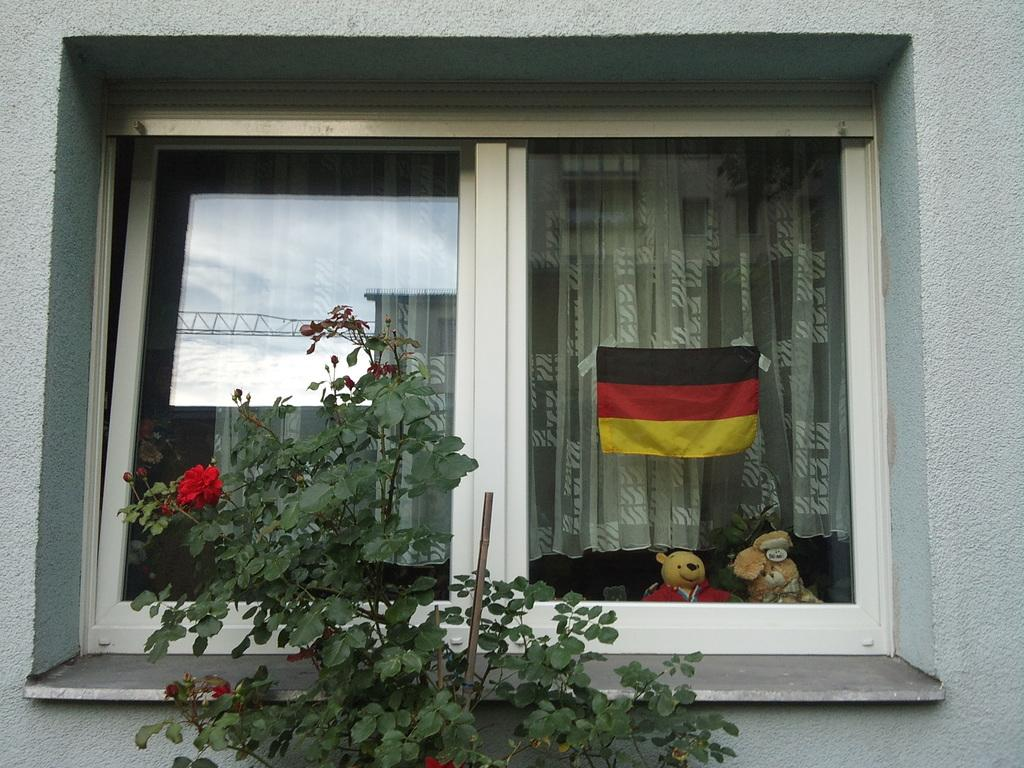What is located in front of the window in the image? There is a plant with flowers in front of the window. What can be seen through the window? A curtain, toys, and a flag are visible through the window. What is the color of the wall in the image? The wall is white. What type of nut is being used to play with the toys in the image? There is no nut present in the image, and no toys are being played with. 